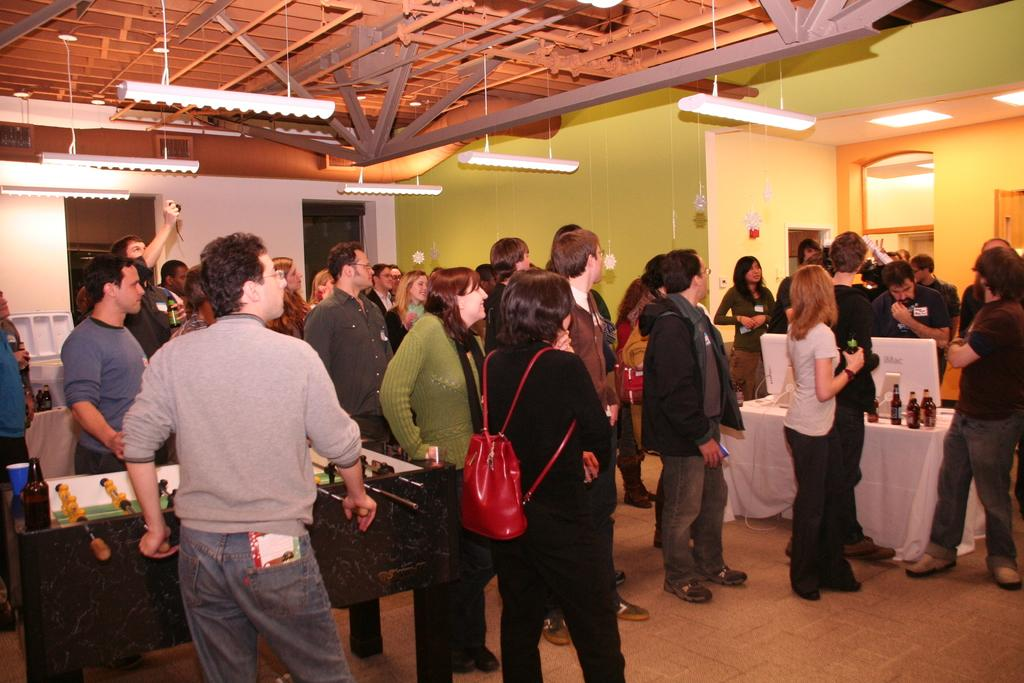Who or what is present in the image? There are people in the image. What object can be seen in the image that is commonly used for eating or working? There is a table in the image. What items are placed on the table in the image? There are bottles and laptops on the table. What can be seen on the roof in the image? There are lights on the roof. How many cobwebs are present in the image? There are no cobwebs visible in the image. 